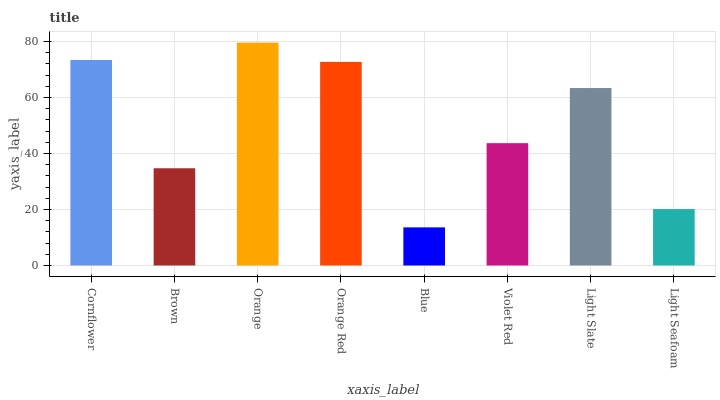Is Blue the minimum?
Answer yes or no. Yes. Is Orange the maximum?
Answer yes or no. Yes. Is Brown the minimum?
Answer yes or no. No. Is Brown the maximum?
Answer yes or no. No. Is Cornflower greater than Brown?
Answer yes or no. Yes. Is Brown less than Cornflower?
Answer yes or no. Yes. Is Brown greater than Cornflower?
Answer yes or no. No. Is Cornflower less than Brown?
Answer yes or no. No. Is Light Slate the high median?
Answer yes or no. Yes. Is Violet Red the low median?
Answer yes or no. Yes. Is Blue the high median?
Answer yes or no. No. Is Light Slate the low median?
Answer yes or no. No. 